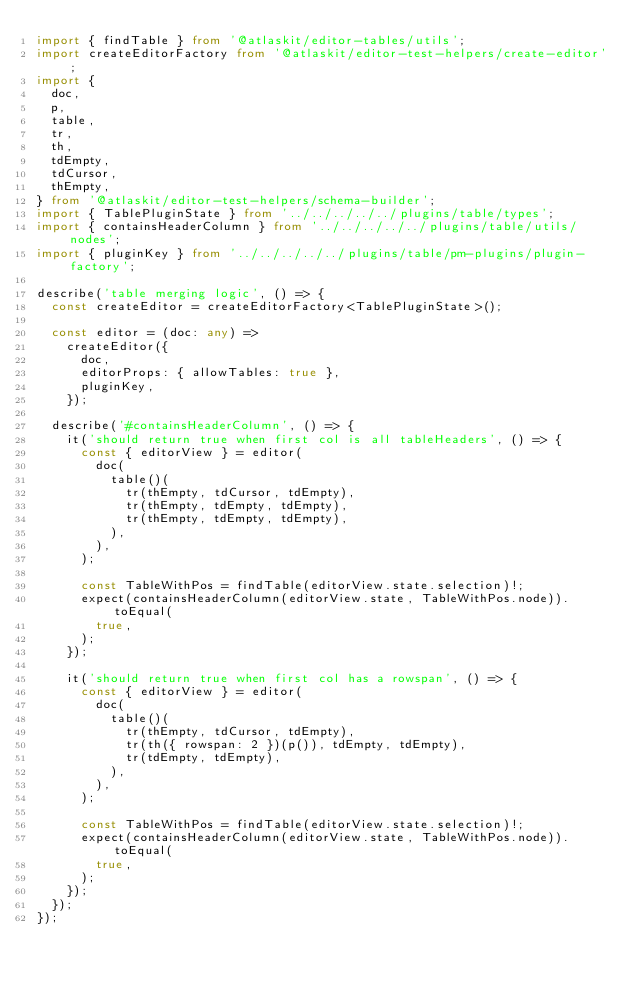<code> <loc_0><loc_0><loc_500><loc_500><_TypeScript_>import { findTable } from '@atlaskit/editor-tables/utils';
import createEditorFactory from '@atlaskit/editor-test-helpers/create-editor';
import {
  doc,
  p,
  table,
  tr,
  th,
  tdEmpty,
  tdCursor,
  thEmpty,
} from '@atlaskit/editor-test-helpers/schema-builder';
import { TablePluginState } from '../../../../../plugins/table/types';
import { containsHeaderColumn } from '../../../../../plugins/table/utils/nodes';
import { pluginKey } from '../../../../../plugins/table/pm-plugins/plugin-factory';

describe('table merging logic', () => {
  const createEditor = createEditorFactory<TablePluginState>();

  const editor = (doc: any) =>
    createEditor({
      doc,
      editorProps: { allowTables: true },
      pluginKey,
    });

  describe('#containsHeaderColumn', () => {
    it('should return true when first col is all tableHeaders', () => {
      const { editorView } = editor(
        doc(
          table()(
            tr(thEmpty, tdCursor, tdEmpty),
            tr(thEmpty, tdEmpty, tdEmpty),
            tr(thEmpty, tdEmpty, tdEmpty),
          ),
        ),
      );

      const TableWithPos = findTable(editorView.state.selection)!;
      expect(containsHeaderColumn(editorView.state, TableWithPos.node)).toEqual(
        true,
      );
    });

    it('should return true when first col has a rowspan', () => {
      const { editorView } = editor(
        doc(
          table()(
            tr(thEmpty, tdCursor, tdEmpty),
            tr(th({ rowspan: 2 })(p()), tdEmpty, tdEmpty),
            tr(tdEmpty, tdEmpty),
          ),
        ),
      );

      const TableWithPos = findTable(editorView.state.selection)!;
      expect(containsHeaderColumn(editorView.state, TableWithPos.node)).toEqual(
        true,
      );
    });
  });
});
</code> 